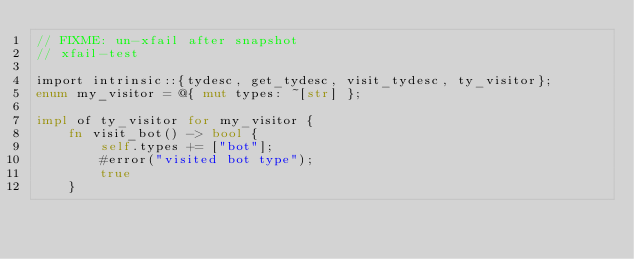Convert code to text. <code><loc_0><loc_0><loc_500><loc_500><_Rust_>// FIXME: un-xfail after snapshot
// xfail-test

import intrinsic::{tydesc, get_tydesc, visit_tydesc, ty_visitor};
enum my_visitor = @{ mut types: ~[str] };

impl of ty_visitor for my_visitor {
    fn visit_bot() -> bool {
        self.types += ["bot"];
        #error("visited bot type");
        true
    }</code> 